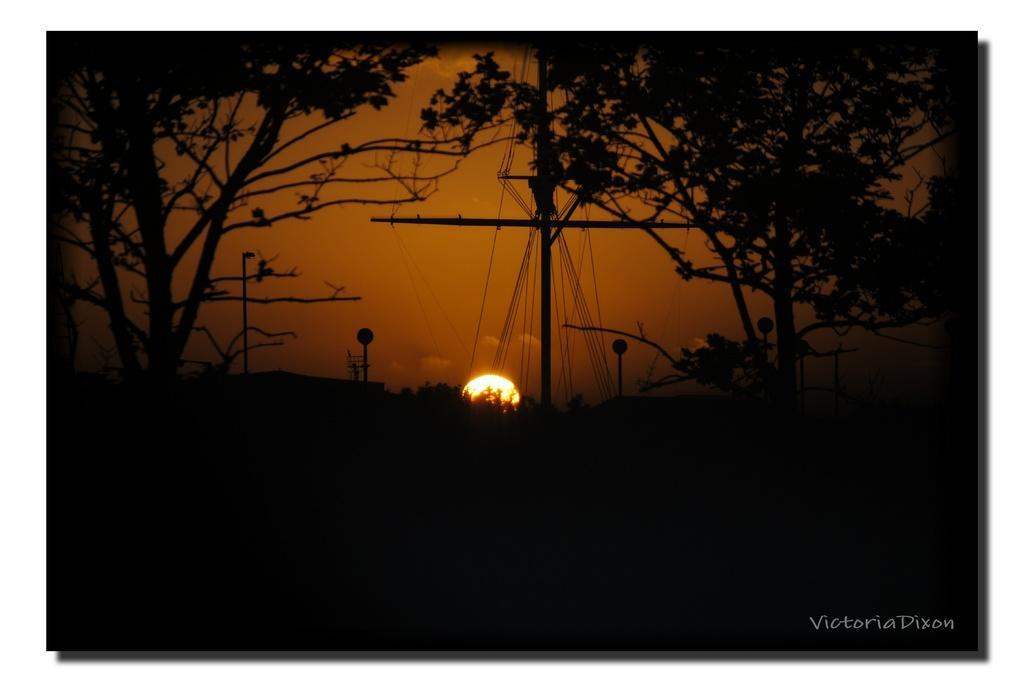In one or two sentences, can you explain what this image depicts? This picture is taken in the dark where we can see trees, current poles, wires, boards, sunset and the sky in the background. Here we can see the watermark at the bottom right side of the image. 